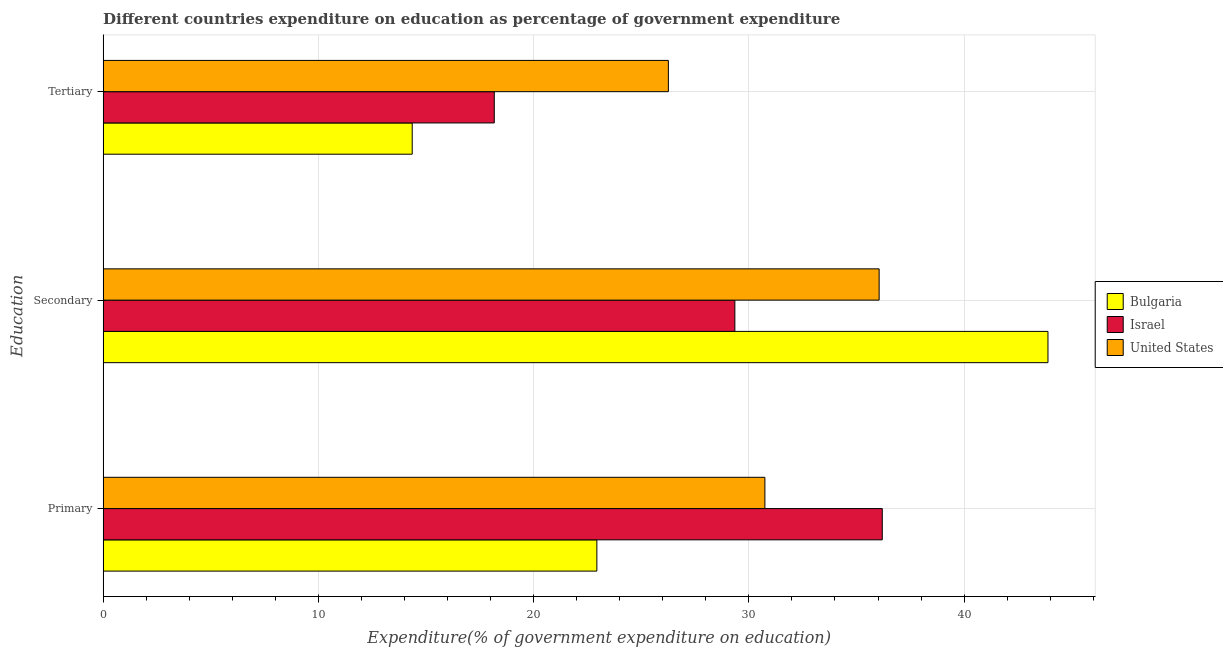How many different coloured bars are there?
Provide a succinct answer. 3. How many groups of bars are there?
Your answer should be compact. 3. How many bars are there on the 3rd tick from the top?
Provide a succinct answer. 3. How many bars are there on the 1st tick from the bottom?
Offer a terse response. 3. What is the label of the 3rd group of bars from the top?
Ensure brevity in your answer.  Primary. What is the expenditure on primary education in United States?
Ensure brevity in your answer.  30.74. Across all countries, what is the maximum expenditure on tertiary education?
Make the answer very short. 26.26. Across all countries, what is the minimum expenditure on primary education?
Ensure brevity in your answer.  22.94. What is the total expenditure on primary education in the graph?
Give a very brief answer. 89.88. What is the difference between the expenditure on secondary education in Bulgaria and that in United States?
Provide a succinct answer. 7.84. What is the difference between the expenditure on primary education in Bulgaria and the expenditure on secondary education in Israel?
Your answer should be very brief. -6.41. What is the average expenditure on tertiary education per country?
Make the answer very short. 19.6. What is the difference between the expenditure on tertiary education and expenditure on primary education in United States?
Provide a succinct answer. -4.48. What is the ratio of the expenditure on tertiary education in United States to that in Bulgaria?
Provide a short and direct response. 1.83. Is the expenditure on secondary education in United States less than that in Bulgaria?
Offer a very short reply. Yes. What is the difference between the highest and the second highest expenditure on primary education?
Give a very brief answer. 5.45. What is the difference between the highest and the lowest expenditure on primary education?
Your answer should be very brief. 13.26. Is the sum of the expenditure on secondary education in United States and Israel greater than the maximum expenditure on primary education across all countries?
Provide a short and direct response. Yes. What does the 2nd bar from the top in Secondary represents?
Keep it short and to the point. Israel. Is it the case that in every country, the sum of the expenditure on primary education and expenditure on secondary education is greater than the expenditure on tertiary education?
Provide a short and direct response. Yes. How many countries are there in the graph?
Offer a terse response. 3. What is the difference between two consecutive major ticks on the X-axis?
Make the answer very short. 10. Are the values on the major ticks of X-axis written in scientific E-notation?
Keep it short and to the point. No. Does the graph contain any zero values?
Your answer should be very brief. No. Does the graph contain grids?
Offer a terse response. Yes. Where does the legend appear in the graph?
Your answer should be compact. Center right. How many legend labels are there?
Provide a succinct answer. 3. What is the title of the graph?
Keep it short and to the point. Different countries expenditure on education as percentage of government expenditure. What is the label or title of the X-axis?
Your answer should be very brief. Expenditure(% of government expenditure on education). What is the label or title of the Y-axis?
Your answer should be compact. Education. What is the Expenditure(% of government expenditure on education) in Bulgaria in Primary?
Offer a very short reply. 22.94. What is the Expenditure(% of government expenditure on education) in Israel in Primary?
Your answer should be very brief. 36.2. What is the Expenditure(% of government expenditure on education) in United States in Primary?
Your answer should be compact. 30.74. What is the Expenditure(% of government expenditure on education) of Bulgaria in Secondary?
Your response must be concise. 43.9. What is the Expenditure(% of government expenditure on education) in Israel in Secondary?
Your answer should be compact. 29.35. What is the Expenditure(% of government expenditure on education) in United States in Secondary?
Your response must be concise. 36.05. What is the Expenditure(% of government expenditure on education) of Bulgaria in Tertiary?
Offer a very short reply. 14.36. What is the Expenditure(% of government expenditure on education) of Israel in Tertiary?
Offer a terse response. 18.17. What is the Expenditure(% of government expenditure on education) in United States in Tertiary?
Provide a short and direct response. 26.26. Across all Education, what is the maximum Expenditure(% of government expenditure on education) in Bulgaria?
Give a very brief answer. 43.9. Across all Education, what is the maximum Expenditure(% of government expenditure on education) of Israel?
Your answer should be very brief. 36.2. Across all Education, what is the maximum Expenditure(% of government expenditure on education) in United States?
Ensure brevity in your answer.  36.05. Across all Education, what is the minimum Expenditure(% of government expenditure on education) in Bulgaria?
Your answer should be compact. 14.36. Across all Education, what is the minimum Expenditure(% of government expenditure on education) in Israel?
Offer a terse response. 18.17. Across all Education, what is the minimum Expenditure(% of government expenditure on education) in United States?
Make the answer very short. 26.26. What is the total Expenditure(% of government expenditure on education) of Bulgaria in the graph?
Your answer should be compact. 81.19. What is the total Expenditure(% of government expenditure on education) of Israel in the graph?
Offer a terse response. 83.72. What is the total Expenditure(% of government expenditure on education) in United States in the graph?
Your response must be concise. 93.06. What is the difference between the Expenditure(% of government expenditure on education) in Bulgaria in Primary and that in Secondary?
Your answer should be compact. -20.96. What is the difference between the Expenditure(% of government expenditure on education) of Israel in Primary and that in Secondary?
Your answer should be compact. 6.85. What is the difference between the Expenditure(% of government expenditure on education) of United States in Primary and that in Secondary?
Offer a very short reply. -5.31. What is the difference between the Expenditure(% of government expenditure on education) in Bulgaria in Primary and that in Tertiary?
Offer a terse response. 8.58. What is the difference between the Expenditure(% of government expenditure on education) of Israel in Primary and that in Tertiary?
Your answer should be compact. 18.03. What is the difference between the Expenditure(% of government expenditure on education) of United States in Primary and that in Tertiary?
Ensure brevity in your answer.  4.48. What is the difference between the Expenditure(% of government expenditure on education) in Bulgaria in Secondary and that in Tertiary?
Provide a succinct answer. 29.54. What is the difference between the Expenditure(% of government expenditure on education) in Israel in Secondary and that in Tertiary?
Your answer should be very brief. 11.18. What is the difference between the Expenditure(% of government expenditure on education) in United States in Secondary and that in Tertiary?
Your response must be concise. 9.79. What is the difference between the Expenditure(% of government expenditure on education) in Bulgaria in Primary and the Expenditure(% of government expenditure on education) in Israel in Secondary?
Your answer should be compact. -6.41. What is the difference between the Expenditure(% of government expenditure on education) of Bulgaria in Primary and the Expenditure(% of government expenditure on education) of United States in Secondary?
Offer a terse response. -13.11. What is the difference between the Expenditure(% of government expenditure on education) of Israel in Primary and the Expenditure(% of government expenditure on education) of United States in Secondary?
Provide a short and direct response. 0.15. What is the difference between the Expenditure(% of government expenditure on education) of Bulgaria in Primary and the Expenditure(% of government expenditure on education) of Israel in Tertiary?
Offer a very short reply. 4.77. What is the difference between the Expenditure(% of government expenditure on education) of Bulgaria in Primary and the Expenditure(% of government expenditure on education) of United States in Tertiary?
Offer a terse response. -3.32. What is the difference between the Expenditure(% of government expenditure on education) of Israel in Primary and the Expenditure(% of government expenditure on education) of United States in Tertiary?
Give a very brief answer. 9.94. What is the difference between the Expenditure(% of government expenditure on education) of Bulgaria in Secondary and the Expenditure(% of government expenditure on education) of Israel in Tertiary?
Offer a terse response. 25.72. What is the difference between the Expenditure(% of government expenditure on education) in Bulgaria in Secondary and the Expenditure(% of government expenditure on education) in United States in Tertiary?
Keep it short and to the point. 17.64. What is the difference between the Expenditure(% of government expenditure on education) in Israel in Secondary and the Expenditure(% of government expenditure on education) in United States in Tertiary?
Keep it short and to the point. 3.09. What is the average Expenditure(% of government expenditure on education) in Bulgaria per Education?
Your answer should be compact. 27.06. What is the average Expenditure(% of government expenditure on education) of Israel per Education?
Keep it short and to the point. 27.91. What is the average Expenditure(% of government expenditure on education) of United States per Education?
Provide a succinct answer. 31.02. What is the difference between the Expenditure(% of government expenditure on education) in Bulgaria and Expenditure(% of government expenditure on education) in Israel in Primary?
Your answer should be compact. -13.26. What is the difference between the Expenditure(% of government expenditure on education) in Bulgaria and Expenditure(% of government expenditure on education) in United States in Primary?
Provide a succinct answer. -7.81. What is the difference between the Expenditure(% of government expenditure on education) of Israel and Expenditure(% of government expenditure on education) of United States in Primary?
Ensure brevity in your answer.  5.45. What is the difference between the Expenditure(% of government expenditure on education) of Bulgaria and Expenditure(% of government expenditure on education) of Israel in Secondary?
Your answer should be compact. 14.55. What is the difference between the Expenditure(% of government expenditure on education) of Bulgaria and Expenditure(% of government expenditure on education) of United States in Secondary?
Your answer should be very brief. 7.84. What is the difference between the Expenditure(% of government expenditure on education) in Israel and Expenditure(% of government expenditure on education) in United States in Secondary?
Offer a terse response. -6.7. What is the difference between the Expenditure(% of government expenditure on education) of Bulgaria and Expenditure(% of government expenditure on education) of Israel in Tertiary?
Offer a very short reply. -3.81. What is the difference between the Expenditure(% of government expenditure on education) of Bulgaria and Expenditure(% of government expenditure on education) of United States in Tertiary?
Provide a short and direct response. -11.9. What is the difference between the Expenditure(% of government expenditure on education) in Israel and Expenditure(% of government expenditure on education) in United States in Tertiary?
Provide a short and direct response. -8.09. What is the ratio of the Expenditure(% of government expenditure on education) in Bulgaria in Primary to that in Secondary?
Offer a terse response. 0.52. What is the ratio of the Expenditure(% of government expenditure on education) in Israel in Primary to that in Secondary?
Your answer should be very brief. 1.23. What is the ratio of the Expenditure(% of government expenditure on education) in United States in Primary to that in Secondary?
Your answer should be very brief. 0.85. What is the ratio of the Expenditure(% of government expenditure on education) of Bulgaria in Primary to that in Tertiary?
Your answer should be very brief. 1.6. What is the ratio of the Expenditure(% of government expenditure on education) in Israel in Primary to that in Tertiary?
Your answer should be very brief. 1.99. What is the ratio of the Expenditure(% of government expenditure on education) in United States in Primary to that in Tertiary?
Offer a terse response. 1.17. What is the ratio of the Expenditure(% of government expenditure on education) of Bulgaria in Secondary to that in Tertiary?
Offer a very short reply. 3.06. What is the ratio of the Expenditure(% of government expenditure on education) of Israel in Secondary to that in Tertiary?
Offer a very short reply. 1.62. What is the ratio of the Expenditure(% of government expenditure on education) of United States in Secondary to that in Tertiary?
Provide a succinct answer. 1.37. What is the difference between the highest and the second highest Expenditure(% of government expenditure on education) in Bulgaria?
Offer a very short reply. 20.96. What is the difference between the highest and the second highest Expenditure(% of government expenditure on education) in Israel?
Give a very brief answer. 6.85. What is the difference between the highest and the second highest Expenditure(% of government expenditure on education) in United States?
Make the answer very short. 5.31. What is the difference between the highest and the lowest Expenditure(% of government expenditure on education) of Bulgaria?
Your answer should be compact. 29.54. What is the difference between the highest and the lowest Expenditure(% of government expenditure on education) in Israel?
Provide a short and direct response. 18.03. What is the difference between the highest and the lowest Expenditure(% of government expenditure on education) in United States?
Your response must be concise. 9.79. 